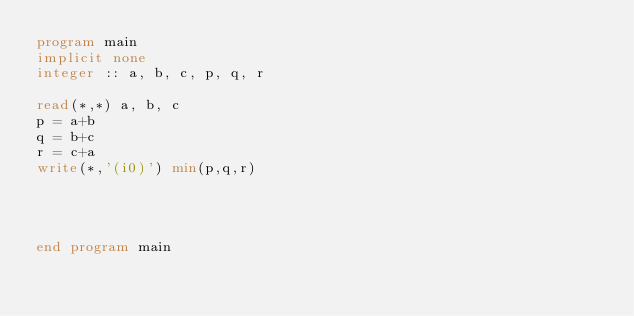Convert code to text. <code><loc_0><loc_0><loc_500><loc_500><_FORTRAN_>program main
implicit none
integer :: a, b, c, p, q, r

read(*,*) a, b, c
p = a+b
q = b+c
r = c+a
write(*,'(i0)') min(p,q,r)




end program main
</code> 